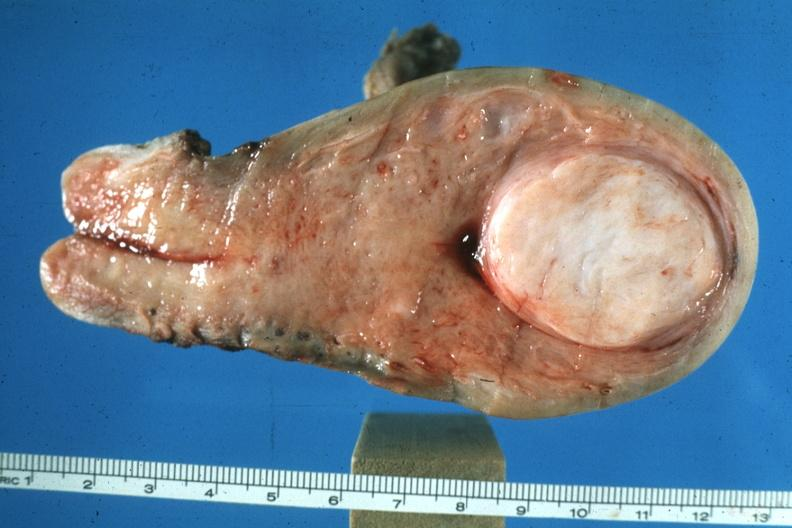what is present?
Answer the question using a single word or phrase. Leiomyoma 